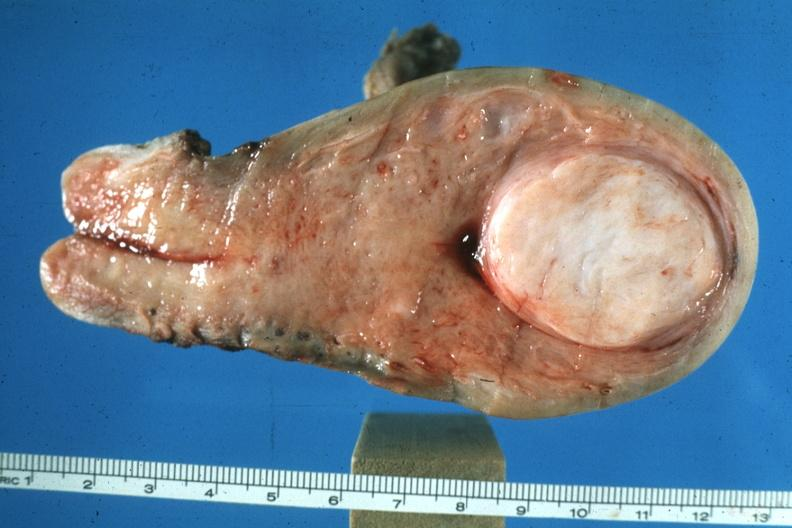what is present?
Answer the question using a single word or phrase. Leiomyoma 